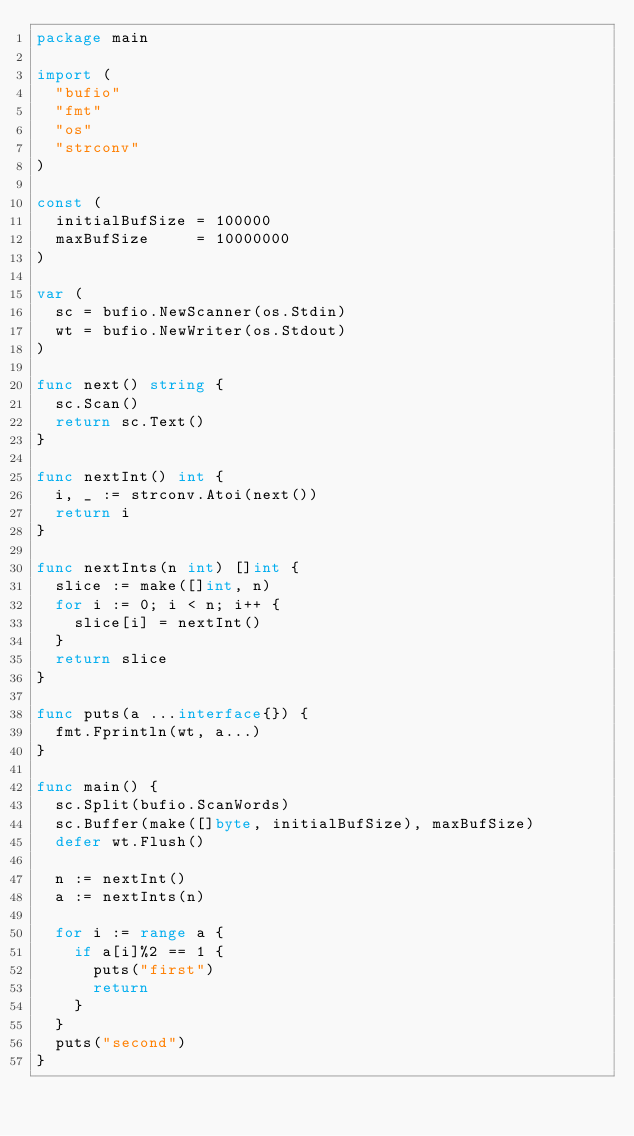<code> <loc_0><loc_0><loc_500><loc_500><_Go_>package main

import (
	"bufio"
	"fmt"
	"os"
	"strconv"
)

const (
	initialBufSize = 100000
	maxBufSize     = 10000000
)

var (
	sc = bufio.NewScanner(os.Stdin)
	wt = bufio.NewWriter(os.Stdout)
)

func next() string {
	sc.Scan()
	return sc.Text()
}

func nextInt() int {
	i, _ := strconv.Atoi(next())
	return i
}

func nextInts(n int) []int {
	slice := make([]int, n)
	for i := 0; i < n; i++ {
		slice[i] = nextInt()
	}
	return slice
}

func puts(a ...interface{}) {
	fmt.Fprintln(wt, a...)
}

func main() {
	sc.Split(bufio.ScanWords)
	sc.Buffer(make([]byte, initialBufSize), maxBufSize)
	defer wt.Flush()

	n := nextInt()
	a := nextInts(n)

	for i := range a {
		if a[i]%2 == 1 {
			puts("first")
			return
		}
	}
	puts("second")
}
</code> 